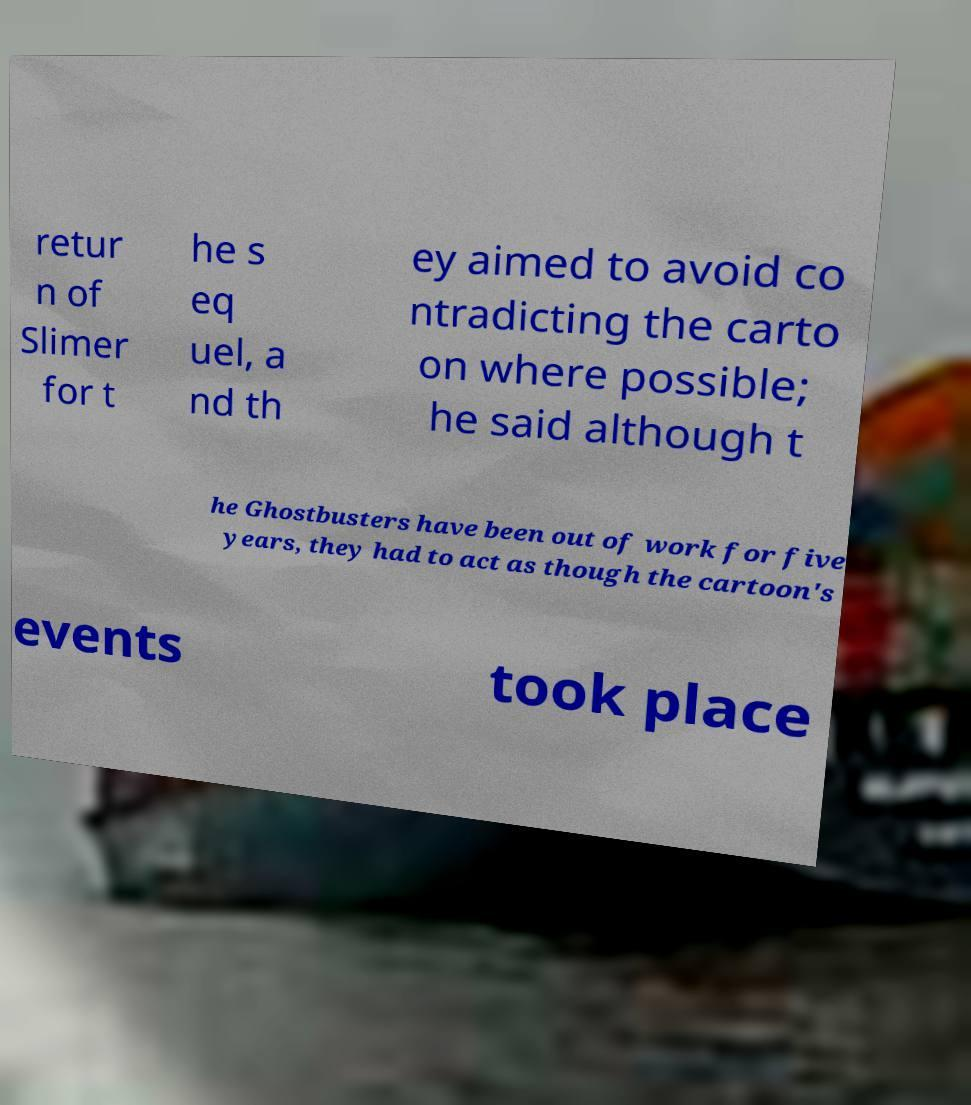Can you accurately transcribe the text from the provided image for me? retur n of Slimer for t he s eq uel, a nd th ey aimed to avoid co ntradicting the carto on where possible; he said although t he Ghostbusters have been out of work for five years, they had to act as though the cartoon's events took place 